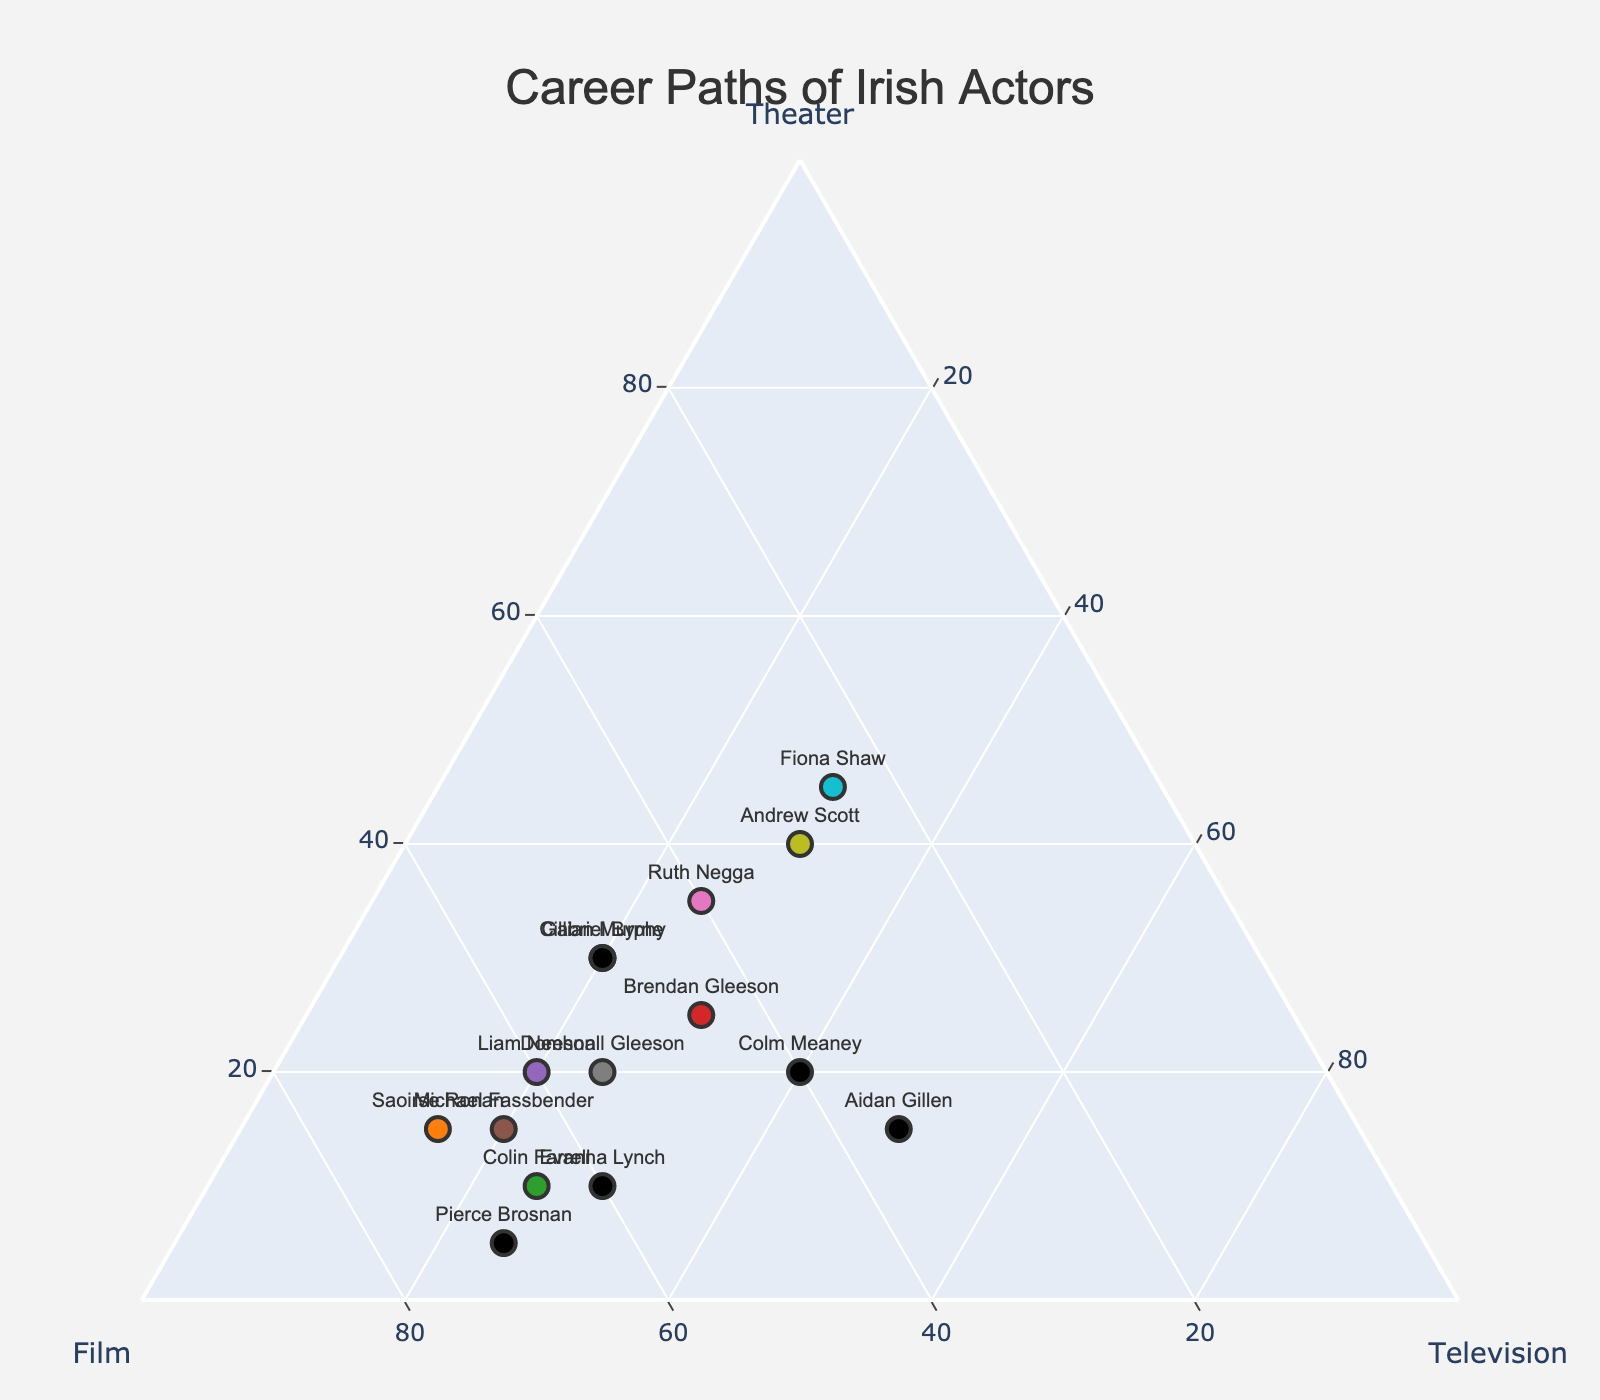What is the title of the ternary plot? The title of a plot is typically located at the top center and is often the largest and boldest text on the figure. In this case, the title provided in the code is "Career Paths of Irish Actors."
Answer: Career Paths of Irish Actors Which actor has spent the most time in theater? Inspect the ternary plot for the actor whose marker is closest to the 'Theater' axis. Actors closer to this vertex have a larger proportion of their career in theater.
Answer: Fiona Shaw What proportion of his career has Pierce Brosnan spent in film? On the ternary plot, locate Pierce Brosnan's marker. The axis labeled 'Film' shows the percentage of his career in film—Brosnan's value near 70% indicates this.
Answer: 70% Which two actors have the same proportion of their careers in television? Compare the positions of all marked characteristics under 'Television' and identify those with equal values. Both Brendan Gleeson and Fiona Shaw have markers at 30% television.
Answer: Brendan Gleeson and Fiona Shaw Who has spent more time in film, Saoirse Ronan or Colin Farrell? Look at the positions of Saoirse Ronan and Colin Farrell in relation to the 'Film' axis. Saoirse Ronan has a value of 70%, whereas Colin Farrell is at 65%.
Answer: Saoirse Ronan Which actor has a career most balanced between theater, film, and television? Identify the marker closest to the center (equidistant from all three axes), representing a balanced career. Andrew Scott, with 40% theater, 30% film, and 30% television, fits this description.
Answer: Andrew Scott What is the total percentage of time Ruth Negga has spent in theater and television? Sum the proportions of Ruth Negga's career in theater and television from the plot, i.e., 35% theater + 25% television = 60%.
Answer: 60% Who has spent less time in theater, Colin Farrell or Evanna Lynch? Compare the theater proportions for Colin Farrell (10%) and Evanna Lynch (10%). Both actors have spent the same amount of time in theater.
Answer: Both Is there any actor who spends equal time in theater and film? Check the positions of the markers in the plot; none of them have equal values for 'Theater' and 'Film.'
Answer: No Which actor has a higher percentage of their career in television compared to theater? Compare percentages under 'Television' and 'Theater' categories. Aidan Gillen (50% television vs 15% theater) has a higher percentage in television than in theater.
Answer: Aidan Gillen 